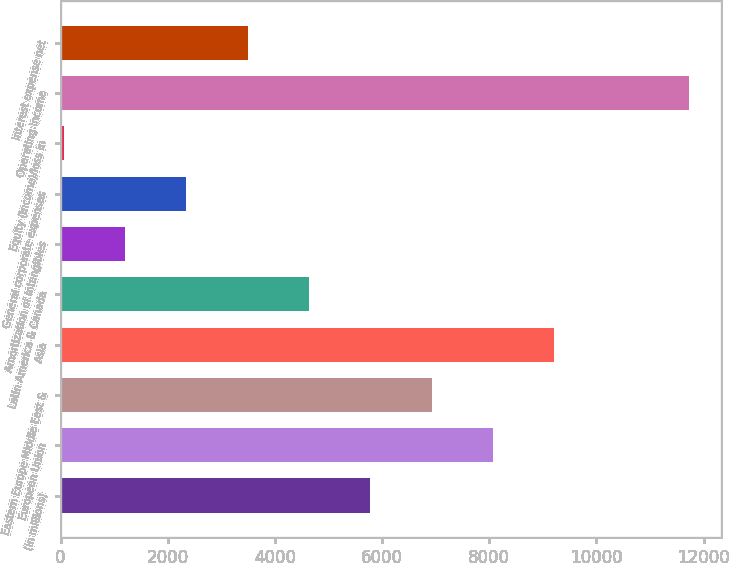<chart> <loc_0><loc_0><loc_500><loc_500><bar_chart><fcel>(in millions)<fcel>European Union<fcel>Eastern Europe Middle East &<fcel>Asia<fcel>Latin America & Canada<fcel>Amortization of intangibles<fcel>General corporate expenses<fcel>Equity (income)/loss in<fcel>Operating income<fcel>Interest expense net<nl><fcel>5781<fcel>8069.8<fcel>6925.4<fcel>9214.2<fcel>4636.6<fcel>1203.4<fcel>2347.8<fcel>59<fcel>11733.4<fcel>3492.2<nl></chart> 